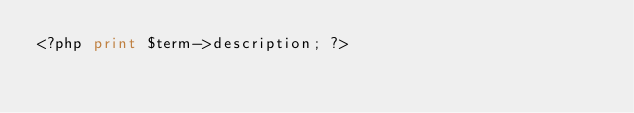<code> <loc_0><loc_0><loc_500><loc_500><_PHP_><?php print $term->description; ?></code> 